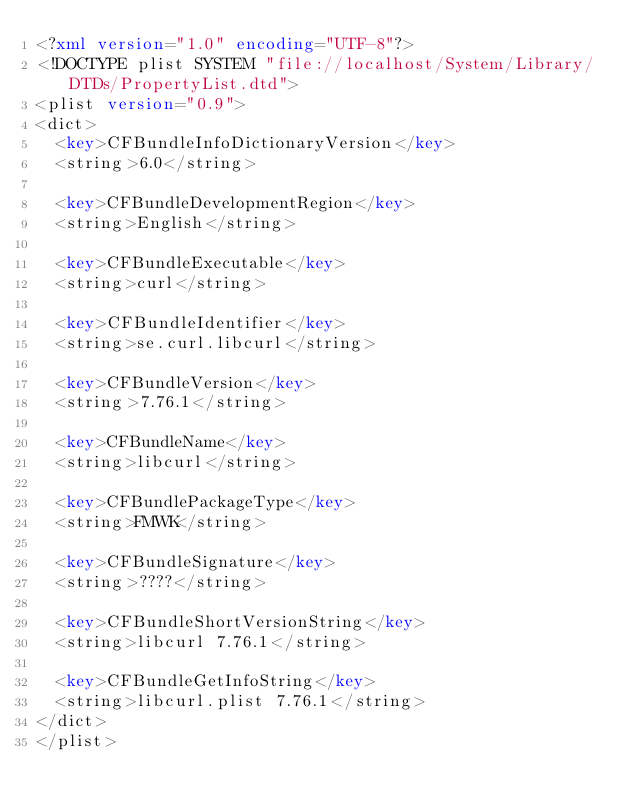Convert code to text. <code><loc_0><loc_0><loc_500><loc_500><_XML_><?xml version="1.0" encoding="UTF-8"?>
<!DOCTYPE plist SYSTEM "file://localhost/System/Library/DTDs/PropertyList.dtd">
<plist version="0.9">
<dict>
	<key>CFBundleInfoDictionaryVersion</key>
	<string>6.0</string>

	<key>CFBundleDevelopmentRegion</key>
	<string>English</string>

	<key>CFBundleExecutable</key>
	<string>curl</string>

	<key>CFBundleIdentifier</key>
	<string>se.curl.libcurl</string>

	<key>CFBundleVersion</key>
	<string>7.76.1</string>

	<key>CFBundleName</key>
	<string>libcurl</string>

	<key>CFBundlePackageType</key>
	<string>FMWK</string>

	<key>CFBundleSignature</key>
	<string>????</string>

	<key>CFBundleShortVersionString</key>
	<string>libcurl 7.76.1</string>

	<key>CFBundleGetInfoString</key>
	<string>libcurl.plist 7.76.1</string>
</dict>
</plist>
</code> 